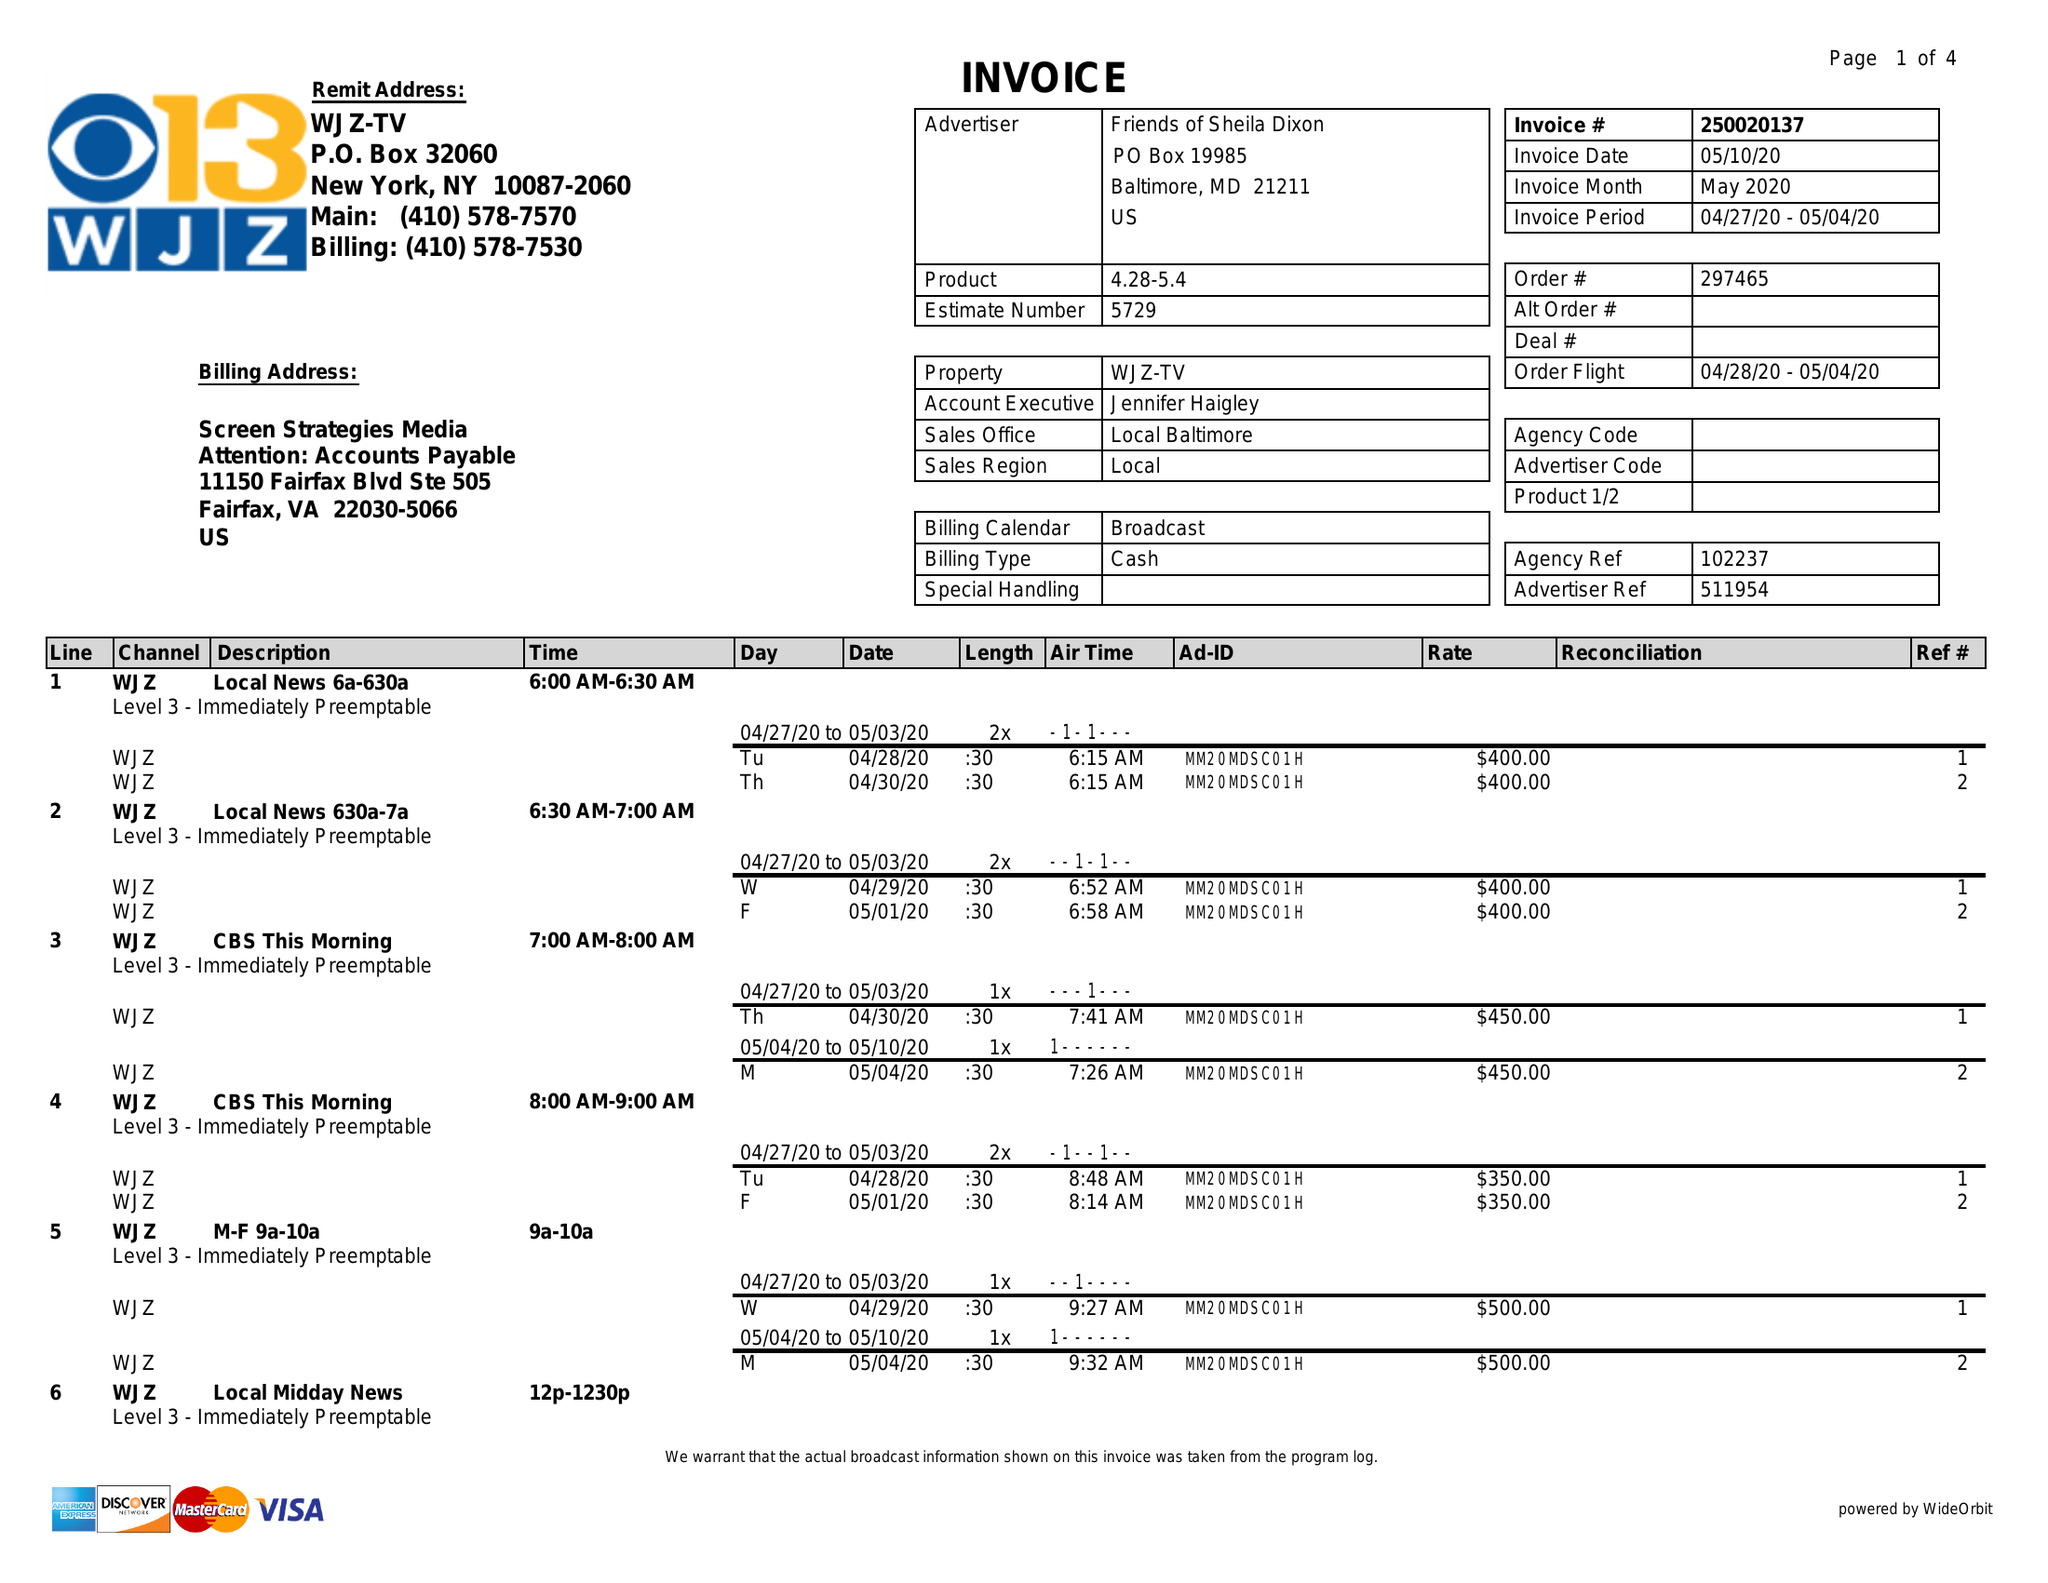What is the value for the flight_from?
Answer the question using a single word or phrase. 04/28/20 